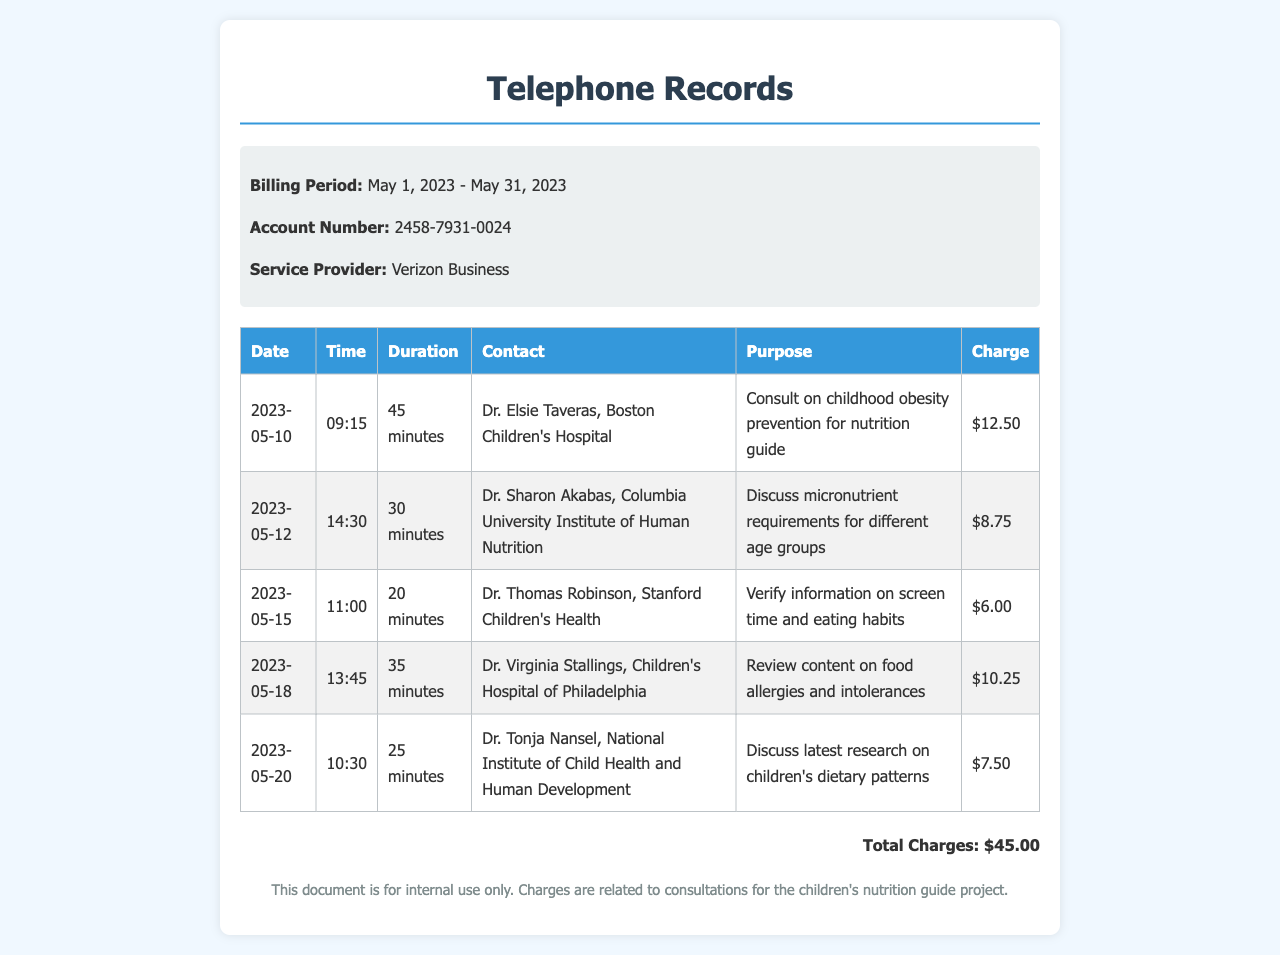What is the billing period? The billing period is specified at the top of the document, which is from May 1, 2023, to May 31, 2023.
Answer: May 1, 2023 - May 31, 2023 Who is the service provider? The service provider for the telephone records is mentioned in the document detail, which is Verizon Business.
Answer: Verizon Business What is the total charge incurred for the consultations? At the bottom of the table, the total charge is calculated as the sum of all individual consultation charges.
Answer: $45.00 Which doctor was consulted on May 12, 2023? The document states the specific doctor consulted on that date along with their affiliation, which is Dr. Sharon Akabas.
Answer: Dr. Sharon Akabas What was the purpose of the call on May 18, 2023? The purpose of the call is provided in the details for that specific date, which was to review content on food allergies and intolerances.
Answer: Review content on food allergies and intolerances How many minutes was the longest consultation? By comparing the durations listed in the table, the longest consultation lasted 45 minutes.
Answer: 45 minutes What is the charge for the consultation with Dr. Thomas Robinson? The specific charge for Dr. Thomas Robinson's consultation is noted in the document under the relevant date entry.
Answer: $6.00 What was discussed during the call with Dr. Tonja Nansel? The document clearly states the topic discussed during that call, which was about the latest research on children's dietary patterns.
Answer: Discuss latest research on children's dietary patterns How many consultations were recorded in total? The total number of consultations can be counted from the entries in the table, which shows five distinct calls.
Answer: 5 